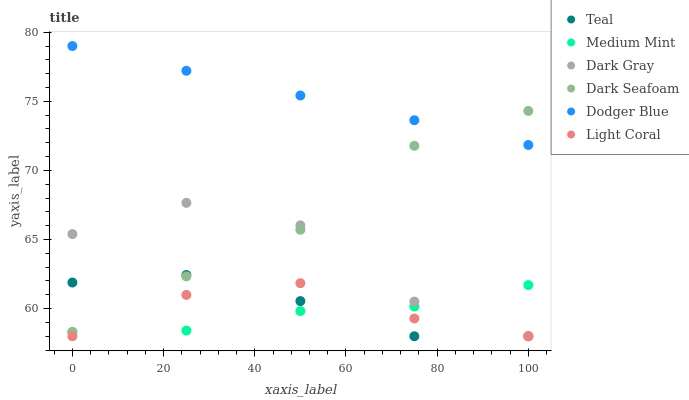Does Medium Mint have the minimum area under the curve?
Answer yes or no. Yes. Does Dodger Blue have the maximum area under the curve?
Answer yes or no. Yes. Does Light Coral have the minimum area under the curve?
Answer yes or no. No. Does Light Coral have the maximum area under the curve?
Answer yes or no. No. Is Dodger Blue the smoothest?
Answer yes or no. Yes. Is Dark Gray the roughest?
Answer yes or no. Yes. Is Light Coral the smoothest?
Answer yes or no. No. Is Light Coral the roughest?
Answer yes or no. No. Does Light Coral have the lowest value?
Answer yes or no. Yes. Does Dark Seafoam have the lowest value?
Answer yes or no. No. Does Dodger Blue have the highest value?
Answer yes or no. Yes. Does Light Coral have the highest value?
Answer yes or no. No. Is Medium Mint less than Dodger Blue?
Answer yes or no. Yes. Is Dark Seafoam greater than Light Coral?
Answer yes or no. Yes. Does Dark Gray intersect Light Coral?
Answer yes or no. Yes. Is Dark Gray less than Light Coral?
Answer yes or no. No. Is Dark Gray greater than Light Coral?
Answer yes or no. No. Does Medium Mint intersect Dodger Blue?
Answer yes or no. No. 